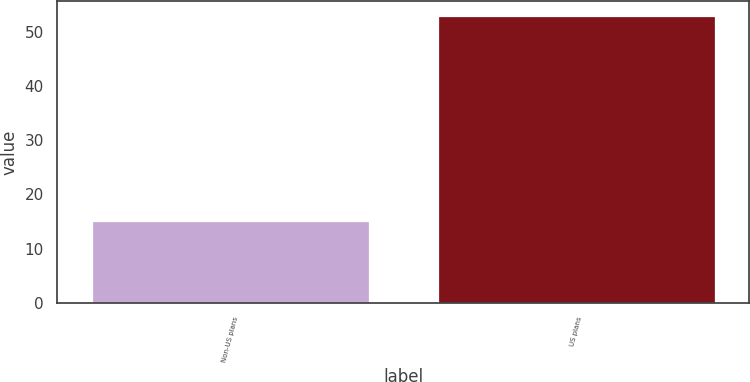Convert chart to OTSL. <chart><loc_0><loc_0><loc_500><loc_500><bar_chart><fcel>Non-US plans<fcel>US plans<nl><fcel>15<fcel>53<nl></chart> 